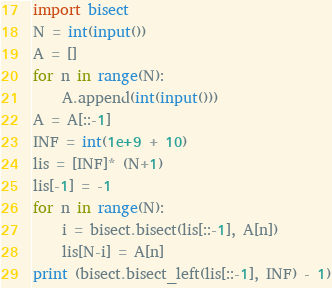<code> <loc_0><loc_0><loc_500><loc_500><_Python_>import bisect
N = int(input())
A = []
for n in range(N):
    A.append(int(input()))
A = A[::-1]
INF = int(1e+9 + 10)
lis = [INF]* (N+1)
lis[-1] = -1
for n in range(N):
    i = bisect.bisect(lis[::-1], A[n])    
    lis[N-i] = A[n]
print (bisect.bisect_left(lis[::-1], INF) - 1)</code> 